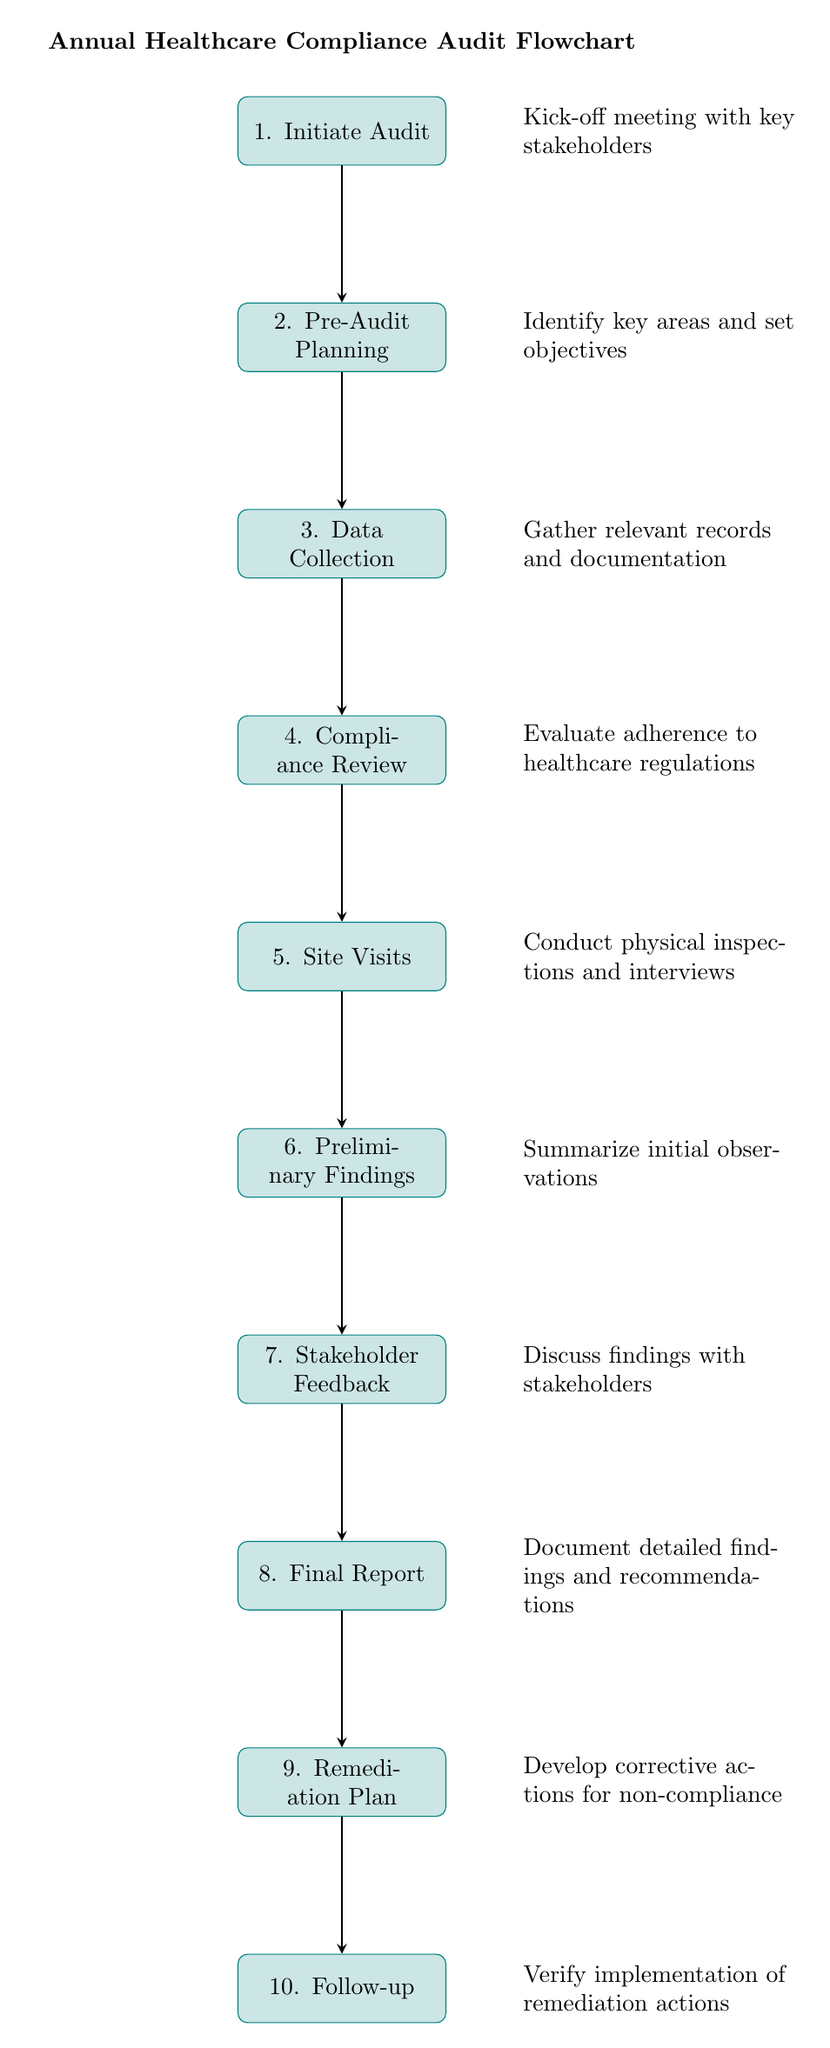What is the first step in the audit? The diagram indicates that the first step in the audit process is labeled as "1. Initiate Audit." This is the starting point of the flowchart and is clearly shown at the top.
Answer: Initiate Audit How many total steps are in the audit flowchart? By counting the processes listed in the diagram, there are ten distinct steps outlined, ranging from "1. Initiate Audit" to "10. Follow-up."
Answer: 10 Which step involves gathering relevant records? The step labeled as "3. Data Collection" corresponds to gathering relevant records and documentation, as indicated in the description connected to this node.
Answer: Data Collection What happens after the Preliminary Findings? Following "6. Preliminary Findings," the next step is "7. Stakeholder Feedback." This indicates that stakeholder feedback is gathered after initial findings are summarized.
Answer: Stakeholder Feedback What is the main activity in the Site Visits step? In "5. Site Visits," the primary activity includes conducting physical inspections and interviews, which is detailed in the corresponding description.
Answer: Conduct physical inspections and interviews In which step is the final report generated? The final report is documented in step "8. Final Report," as outlined in the flowchart, which follows the Stakeholder Feedback.
Answer: Final Report What is the purpose of the Remediation Plan step? The "9. Remediation Plan" step is aimed at developing corrective actions for non-compliance, which helps to address any issues found during the audit.
Answer: Develop corrective actions for non-compliance How is the flow between the Compliance Review and Site Visits steps? The flowchart illustrates a direct connection (arrow) from "4. Compliance Review" to "5. Site Visits," indicating that after reviewing compliance, site visits are conducted next.
Answer: Direct connection What is the purpose of the Follow-up step? The purpose of the "10. Follow-up" step is to verify the implementation of remediation actions, ensuring that corrective measures have been properly enacted.
Answer: Verify implementation of remediation actions What element indicates stakeholder involvement in the audit? The step "7. Stakeholder Feedback" explicitly highlights stakeholder involvement, showcasing that their feedback is an integral part of the audit process.
Answer: Stakeholder Feedback 